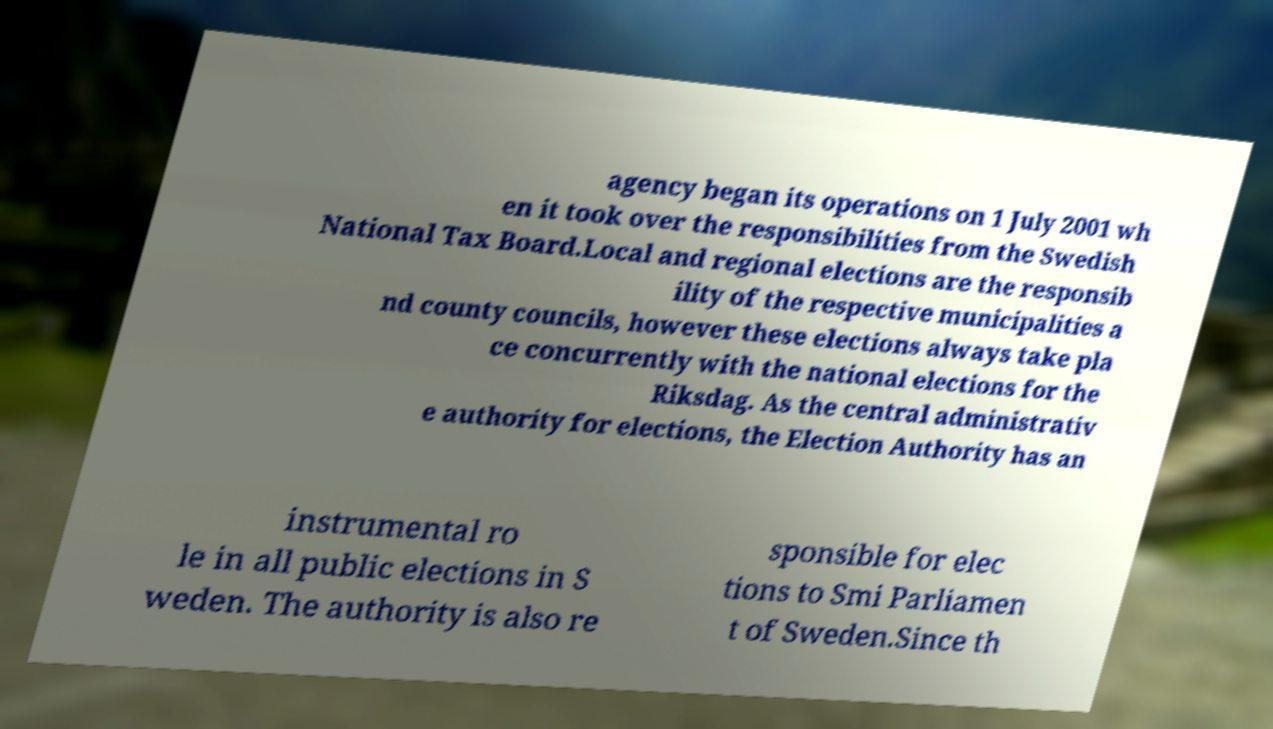For documentation purposes, I need the text within this image transcribed. Could you provide that? agency began its operations on 1 July 2001 wh en it took over the responsibilities from the Swedish National Tax Board.Local and regional elections are the responsib ility of the respective municipalities a nd county councils, however these elections always take pla ce concurrently with the national elections for the Riksdag. As the central administrativ e authority for elections, the Election Authority has an instrumental ro le in all public elections in S weden. The authority is also re sponsible for elec tions to Smi Parliamen t of Sweden.Since th 